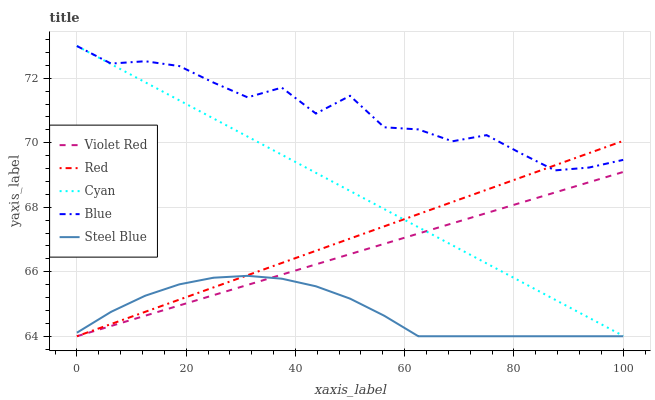Does Steel Blue have the minimum area under the curve?
Answer yes or no. Yes. Does Blue have the maximum area under the curve?
Answer yes or no. Yes. Does Cyan have the minimum area under the curve?
Answer yes or no. No. Does Cyan have the maximum area under the curve?
Answer yes or no. No. Is Violet Red the smoothest?
Answer yes or no. Yes. Is Blue the roughest?
Answer yes or no. Yes. Is Cyan the smoothest?
Answer yes or no. No. Is Cyan the roughest?
Answer yes or no. No. Does Cyan have the lowest value?
Answer yes or no. No. Does Violet Red have the highest value?
Answer yes or no. No. Is Violet Red less than Blue?
Answer yes or no. Yes. Is Blue greater than Steel Blue?
Answer yes or no. Yes. Does Violet Red intersect Blue?
Answer yes or no. No. 